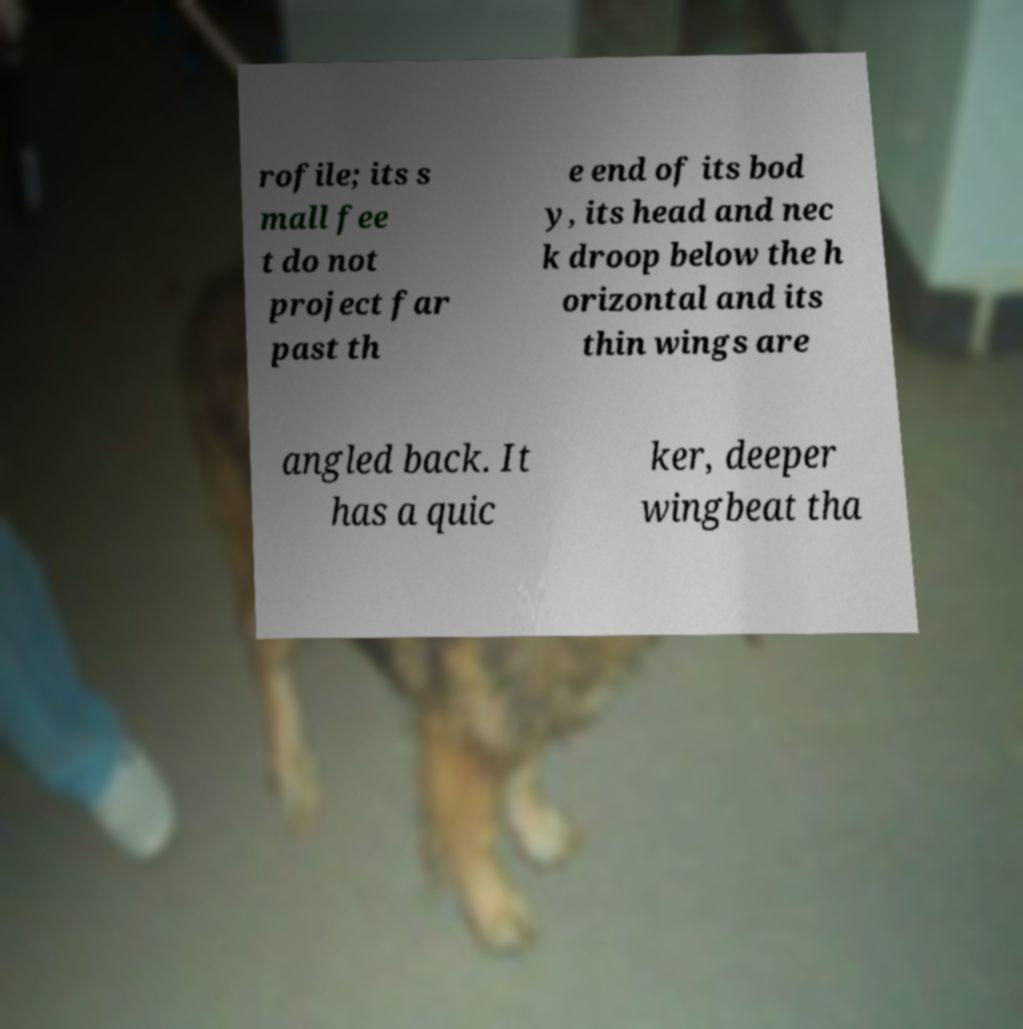Please identify and transcribe the text found in this image. rofile; its s mall fee t do not project far past th e end of its bod y, its head and nec k droop below the h orizontal and its thin wings are angled back. It has a quic ker, deeper wingbeat tha 